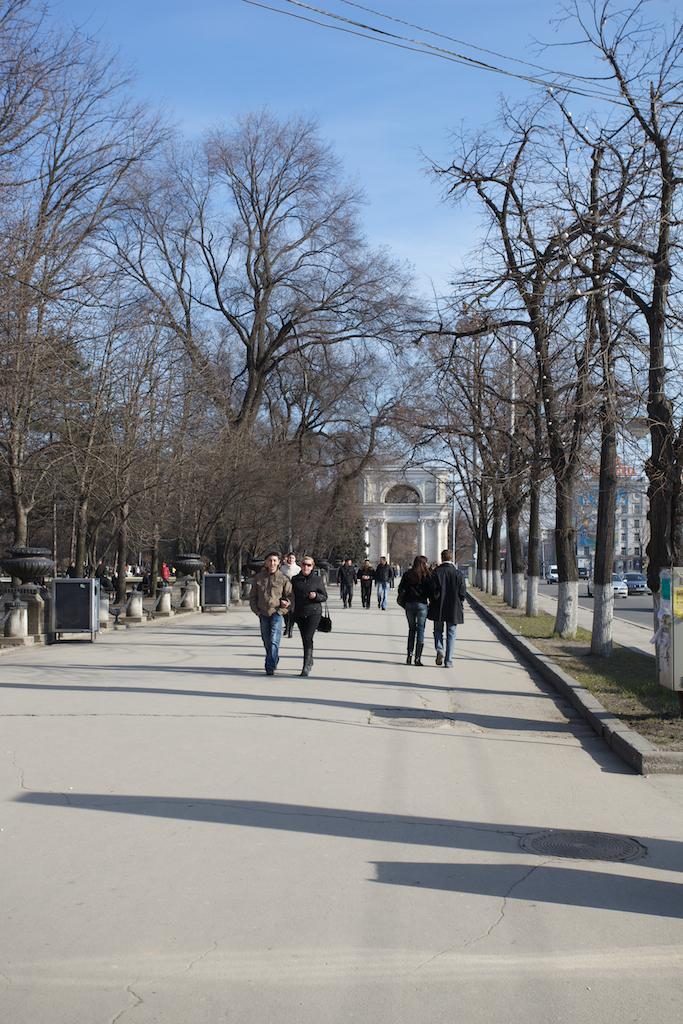Describe this image in one or two sentences. In this image there is a road on which there are few people walking on it. There are trees on either side of the road. In the middle it seems like an arch. In the background there are buildings. On the right side there is another road on which there are vehicles. At the top there is the sky. 